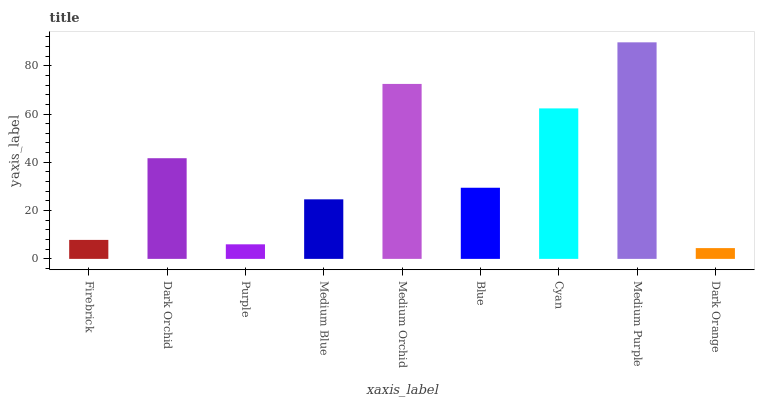Is Dark Orange the minimum?
Answer yes or no. Yes. Is Medium Purple the maximum?
Answer yes or no. Yes. Is Dark Orchid the minimum?
Answer yes or no. No. Is Dark Orchid the maximum?
Answer yes or no. No. Is Dark Orchid greater than Firebrick?
Answer yes or no. Yes. Is Firebrick less than Dark Orchid?
Answer yes or no. Yes. Is Firebrick greater than Dark Orchid?
Answer yes or no. No. Is Dark Orchid less than Firebrick?
Answer yes or no. No. Is Blue the high median?
Answer yes or no. Yes. Is Blue the low median?
Answer yes or no. Yes. Is Purple the high median?
Answer yes or no. No. Is Dark Orange the low median?
Answer yes or no. No. 